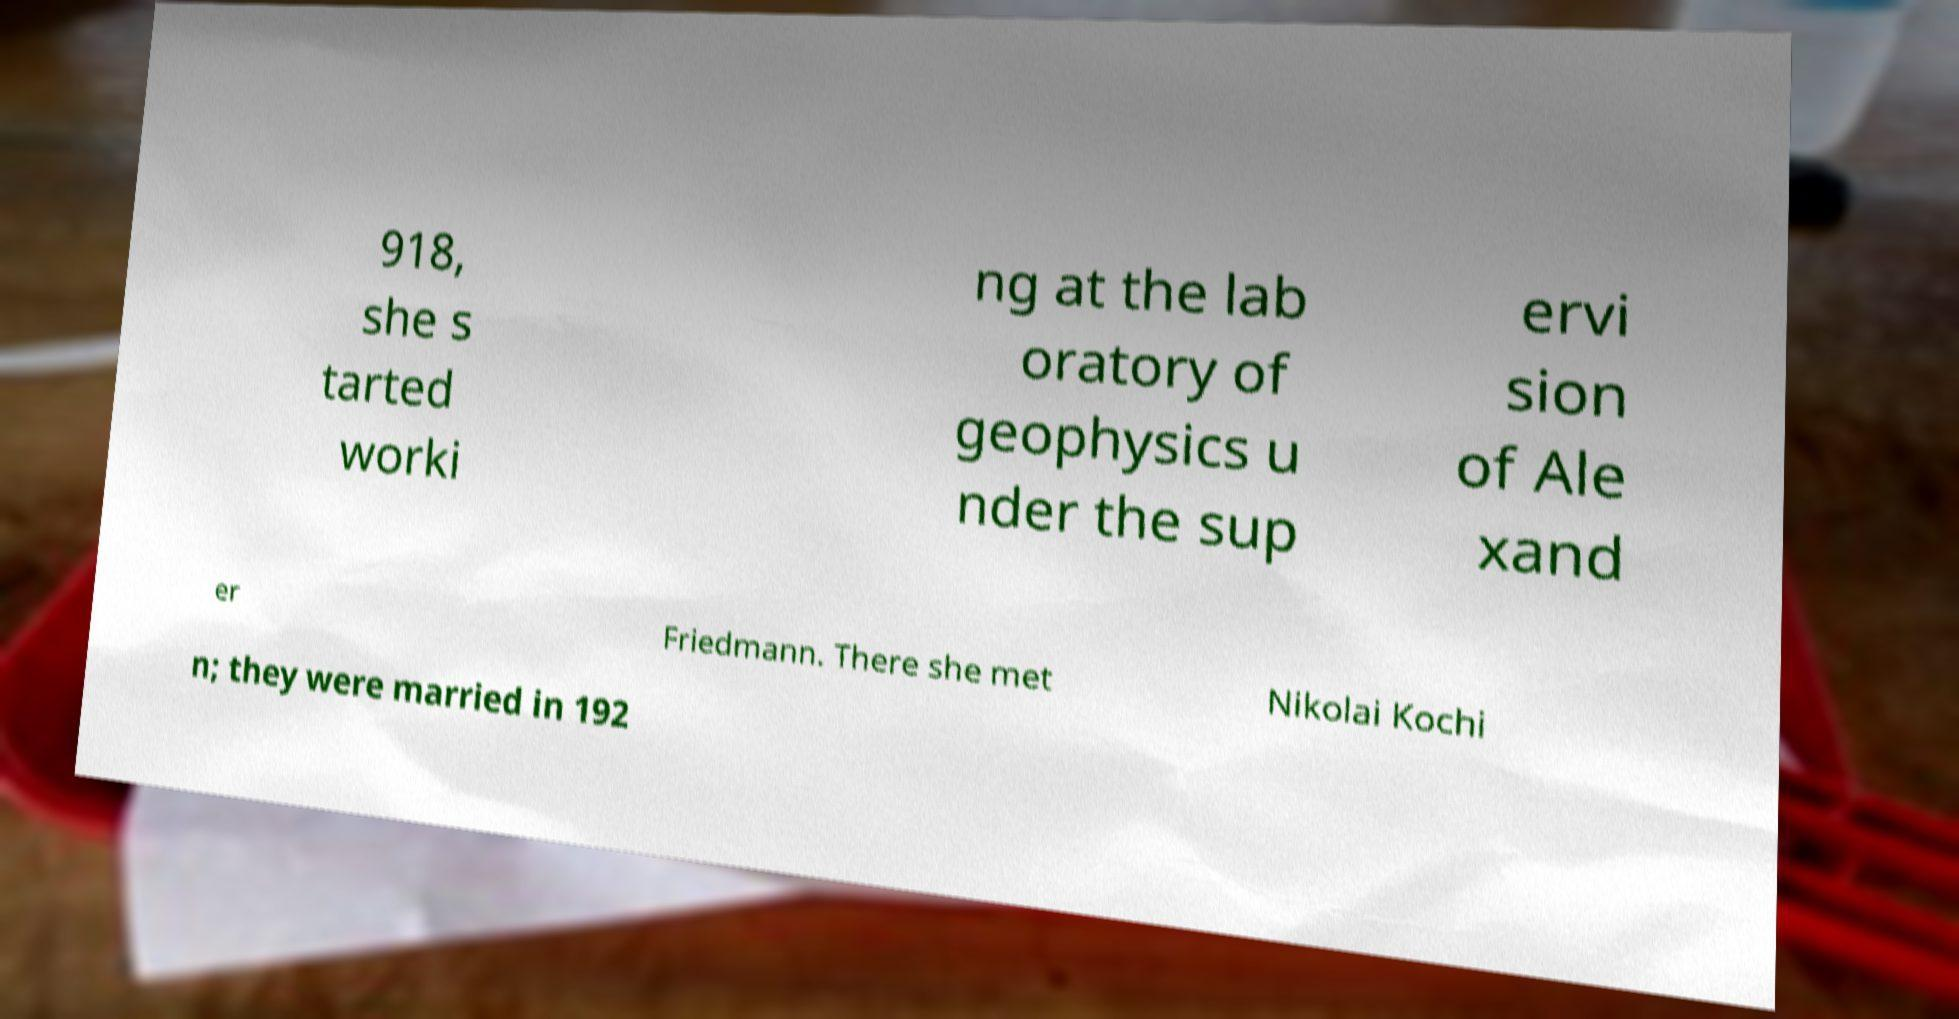Can you accurately transcribe the text from the provided image for me? 918, she s tarted worki ng at the lab oratory of geophysics u nder the sup ervi sion of Ale xand er Friedmann. There she met Nikolai Kochi n; they were married in 192 